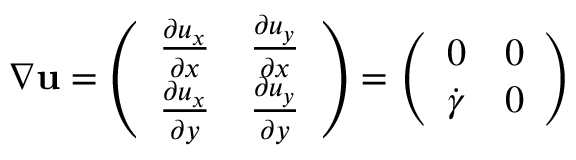<formula> <loc_0><loc_0><loc_500><loc_500>\nabla { u } = \left ( \begin{array} { l l } { \frac { \partial u _ { x } } { \partial x } } & { \frac { \partial u _ { y } } { \partial x } } \\ { \frac { \partial u _ { x } } { \partial y } } & { \frac { \partial u _ { y } } { \partial y } } \end{array} \right ) = \left ( \begin{array} { l l } { 0 } & { 0 } \\ { \dot { \gamma } } & { 0 } \end{array} \right )</formula> 